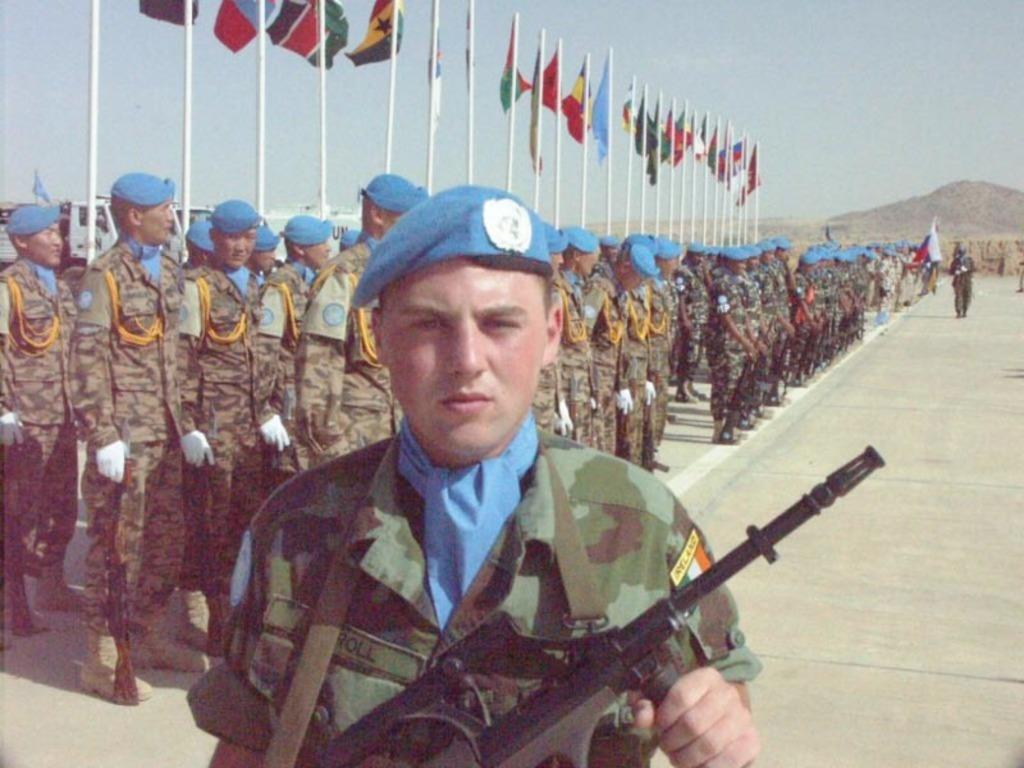What is the main subject of the image? There is a man in the image. What is the man holding in his hand? The man is holding a weapon in his hand. Can you describe the man's clothing? The man is wearing a blue cap. What can be seen behind the man? There is a group of people behind the man. What is the weather like in the image? The sky is visible at the top of the image, and it appears to be sunny. How many kittens are sitting on the man's shoulder in the image? There are no kittens present in the image. What type of soup is being served to the group of people behind the man? There is no soup visible in the image. 